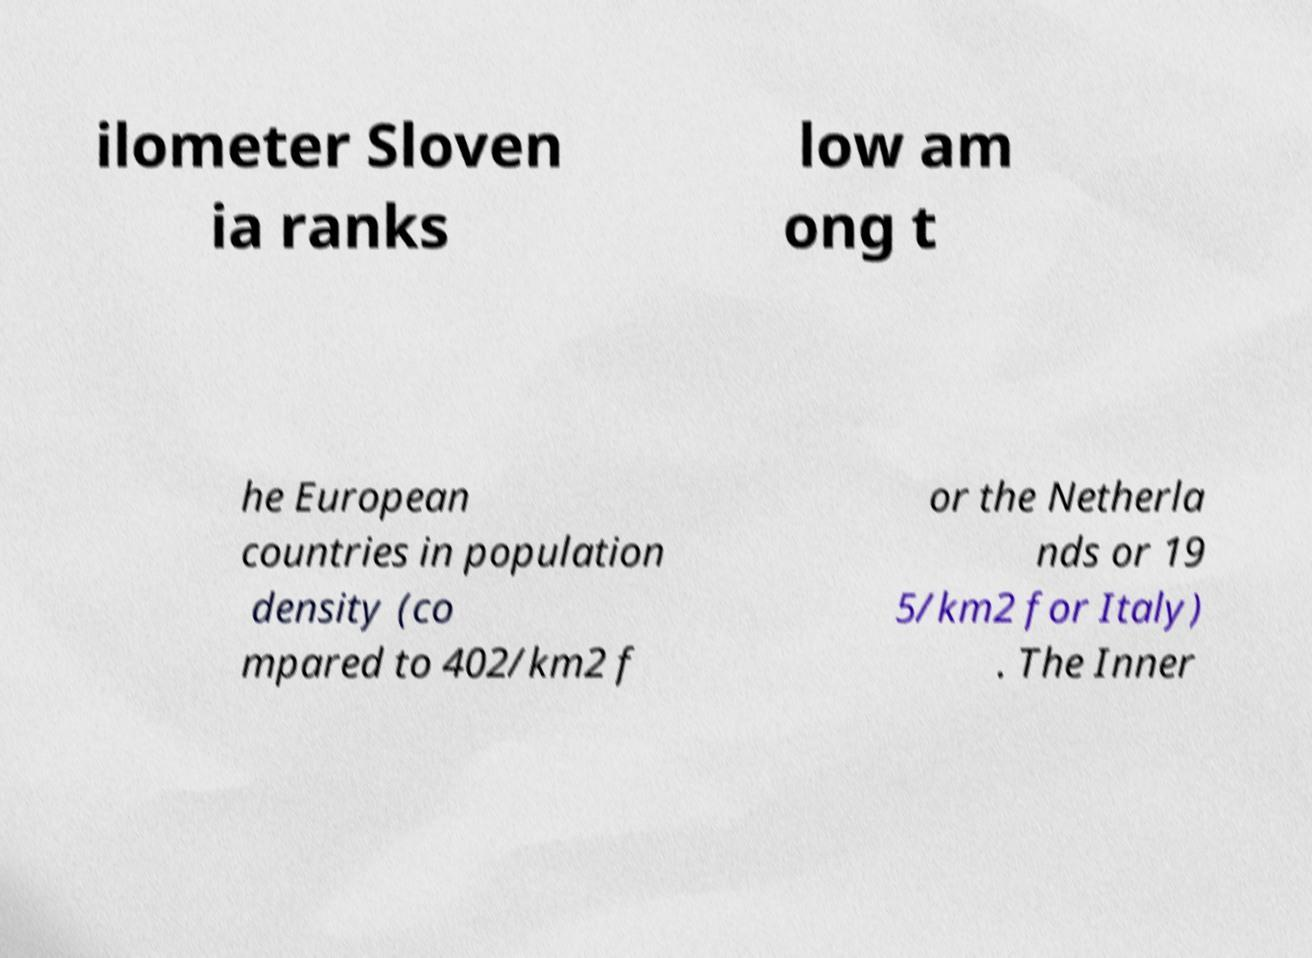For documentation purposes, I need the text within this image transcribed. Could you provide that? ilometer Sloven ia ranks low am ong t he European countries in population density (co mpared to 402/km2 f or the Netherla nds or 19 5/km2 for Italy) . The Inner 